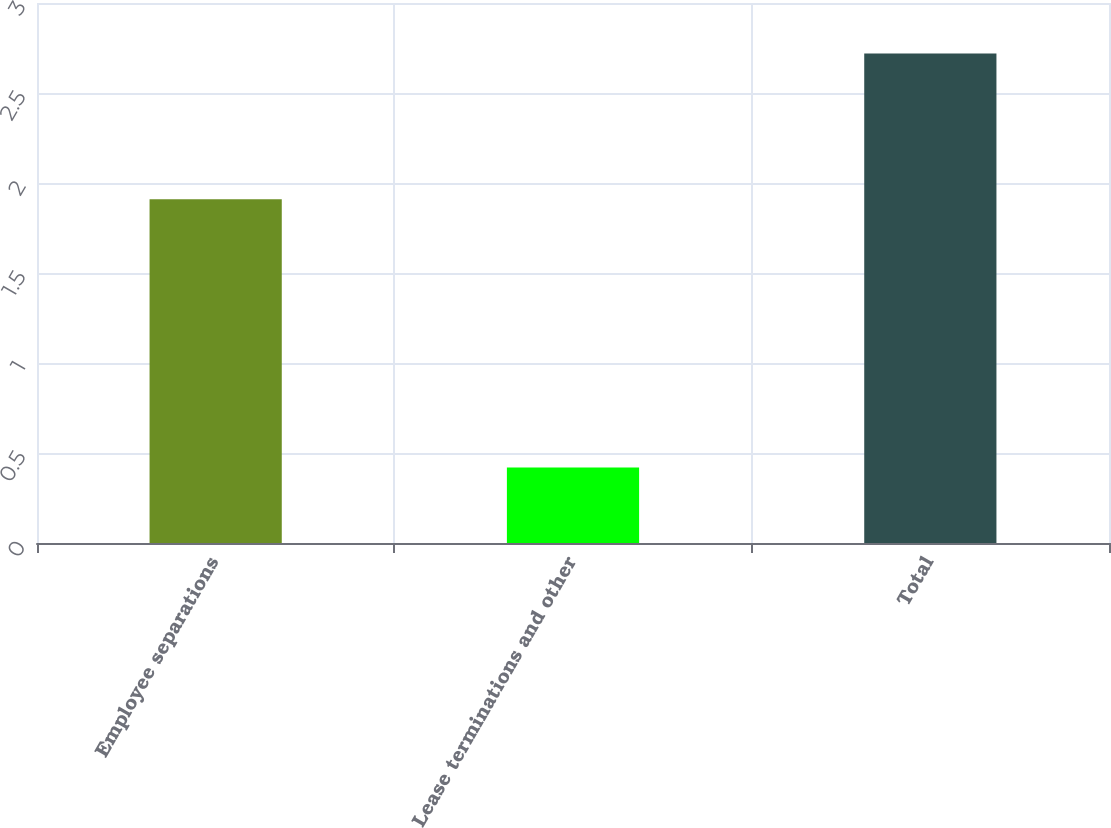Convert chart to OTSL. <chart><loc_0><loc_0><loc_500><loc_500><bar_chart><fcel>Employee separations<fcel>Lease terminations and other<fcel>Total<nl><fcel>1.91<fcel>0.42<fcel>2.72<nl></chart> 